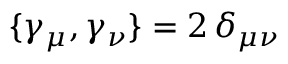Convert formula to latex. <formula><loc_0><loc_0><loc_500><loc_500>\{ \gamma _ { \mu } , \gamma _ { \nu } \} = 2 \, \delta _ { \mu \nu }</formula> 